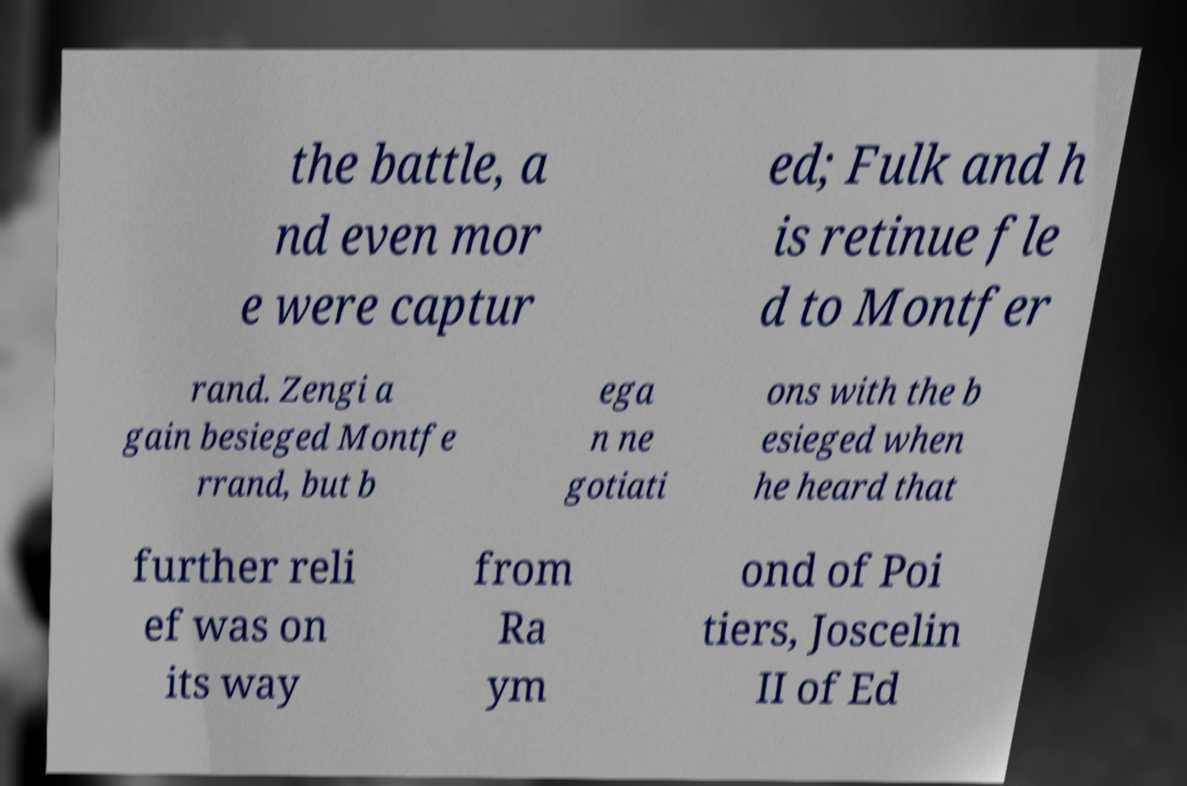What messages or text are displayed in this image? I need them in a readable, typed format. the battle, a nd even mor e were captur ed; Fulk and h is retinue fle d to Montfer rand. Zengi a gain besieged Montfe rrand, but b ega n ne gotiati ons with the b esieged when he heard that further reli ef was on its way from Ra ym ond of Poi tiers, Joscelin II of Ed 